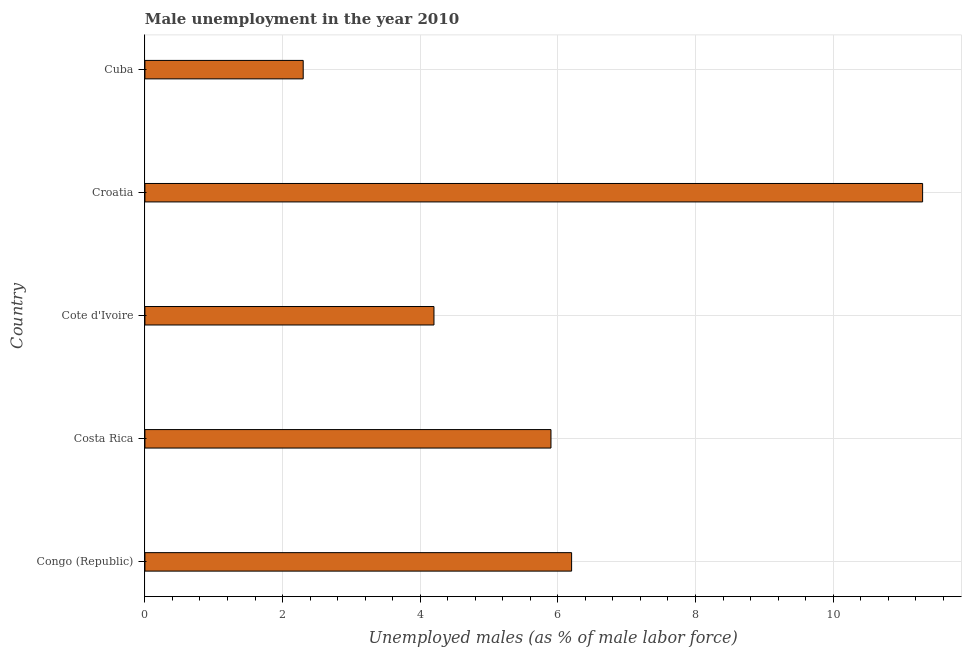Does the graph contain grids?
Your answer should be compact. Yes. What is the title of the graph?
Offer a terse response. Male unemployment in the year 2010. What is the label or title of the X-axis?
Your answer should be very brief. Unemployed males (as % of male labor force). What is the label or title of the Y-axis?
Keep it short and to the point. Country. What is the unemployed males population in Costa Rica?
Make the answer very short. 5.9. Across all countries, what is the maximum unemployed males population?
Keep it short and to the point. 11.3. Across all countries, what is the minimum unemployed males population?
Ensure brevity in your answer.  2.3. In which country was the unemployed males population maximum?
Give a very brief answer. Croatia. In which country was the unemployed males population minimum?
Give a very brief answer. Cuba. What is the sum of the unemployed males population?
Offer a very short reply. 29.9. What is the average unemployed males population per country?
Provide a succinct answer. 5.98. What is the median unemployed males population?
Make the answer very short. 5.9. What is the ratio of the unemployed males population in Croatia to that in Cuba?
Your answer should be compact. 4.91. Is the unemployed males population in Costa Rica less than that in Cuba?
Provide a succinct answer. No. What is the difference between the highest and the second highest unemployed males population?
Offer a very short reply. 5.1. Are all the bars in the graph horizontal?
Your answer should be compact. Yes. How many countries are there in the graph?
Offer a terse response. 5. Are the values on the major ticks of X-axis written in scientific E-notation?
Your answer should be compact. No. What is the Unemployed males (as % of male labor force) in Congo (Republic)?
Your answer should be compact. 6.2. What is the Unemployed males (as % of male labor force) of Costa Rica?
Your response must be concise. 5.9. What is the Unemployed males (as % of male labor force) of Cote d'Ivoire?
Keep it short and to the point. 4.2. What is the Unemployed males (as % of male labor force) in Croatia?
Ensure brevity in your answer.  11.3. What is the Unemployed males (as % of male labor force) in Cuba?
Provide a succinct answer. 2.3. What is the difference between the Unemployed males (as % of male labor force) in Congo (Republic) and Costa Rica?
Offer a very short reply. 0.3. What is the difference between the Unemployed males (as % of male labor force) in Congo (Republic) and Croatia?
Your answer should be compact. -5.1. What is the difference between the Unemployed males (as % of male labor force) in Congo (Republic) and Cuba?
Offer a terse response. 3.9. What is the difference between the Unemployed males (as % of male labor force) in Cote d'Ivoire and Croatia?
Your answer should be very brief. -7.1. What is the difference between the Unemployed males (as % of male labor force) in Cote d'Ivoire and Cuba?
Provide a short and direct response. 1.9. What is the ratio of the Unemployed males (as % of male labor force) in Congo (Republic) to that in Costa Rica?
Offer a terse response. 1.05. What is the ratio of the Unemployed males (as % of male labor force) in Congo (Republic) to that in Cote d'Ivoire?
Keep it short and to the point. 1.48. What is the ratio of the Unemployed males (as % of male labor force) in Congo (Republic) to that in Croatia?
Keep it short and to the point. 0.55. What is the ratio of the Unemployed males (as % of male labor force) in Congo (Republic) to that in Cuba?
Your response must be concise. 2.7. What is the ratio of the Unemployed males (as % of male labor force) in Costa Rica to that in Cote d'Ivoire?
Offer a very short reply. 1.41. What is the ratio of the Unemployed males (as % of male labor force) in Costa Rica to that in Croatia?
Offer a terse response. 0.52. What is the ratio of the Unemployed males (as % of male labor force) in Costa Rica to that in Cuba?
Your response must be concise. 2.56. What is the ratio of the Unemployed males (as % of male labor force) in Cote d'Ivoire to that in Croatia?
Provide a succinct answer. 0.37. What is the ratio of the Unemployed males (as % of male labor force) in Cote d'Ivoire to that in Cuba?
Provide a short and direct response. 1.83. What is the ratio of the Unemployed males (as % of male labor force) in Croatia to that in Cuba?
Your answer should be very brief. 4.91. 